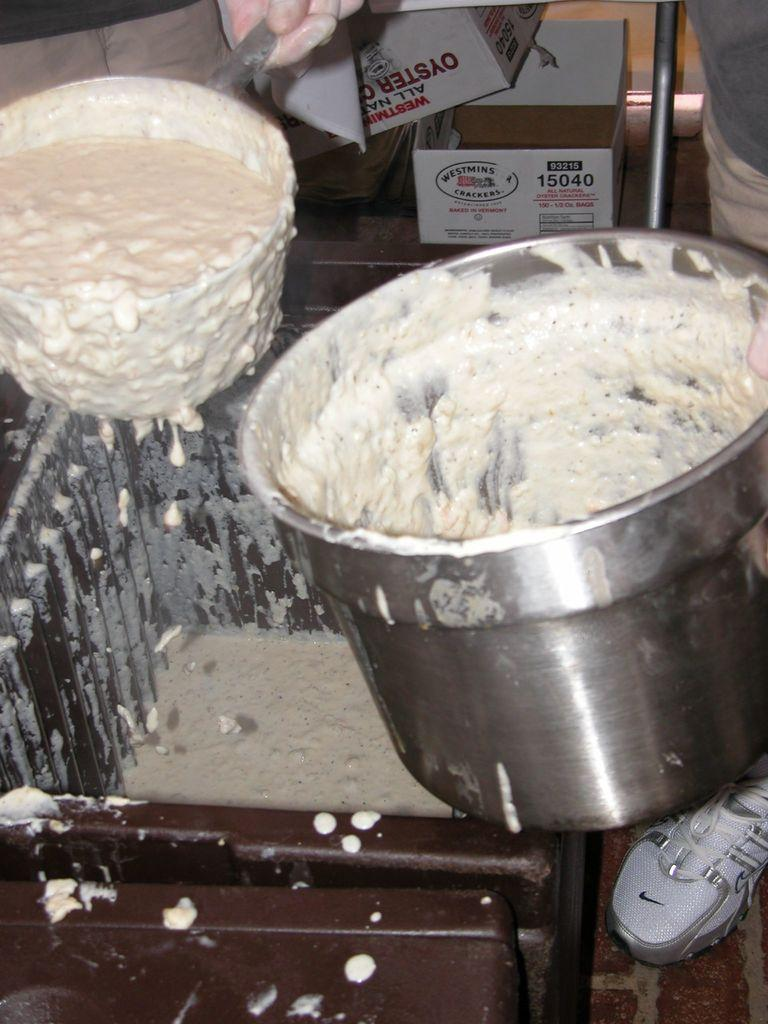Who or what is present in the image? There are people in the image. What are the people wearing on their feet? The people are wearing white shoes. What are the people holding in the image? The people are holding a batter. What objects can be seen in the image besides the people? There are two white boxes in the image. What is written or printed on the boxes? There is text on the boxes. Are there any servants in the image? There is no mention of servants in the image or the provided facts. 